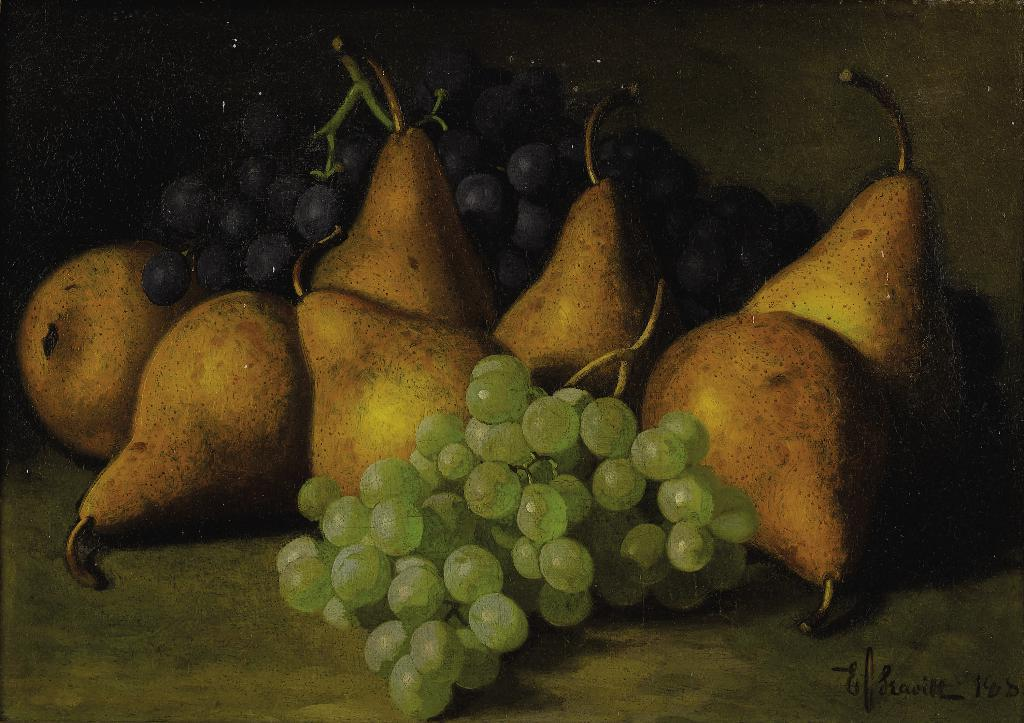What type of fruit can be seen in the image? There are grapes and pears in the image. Can you describe the color and shape of the grapes? The grapes are small, round, and have a dark purple color. How do the pears appear in the image? The pears are larger than the grapes, have an elongated shape, and have a yellowish-green color. What language is being spoken by the toy in the image? There is no toy present in the image, and therefore no language being spoken by a toy. 